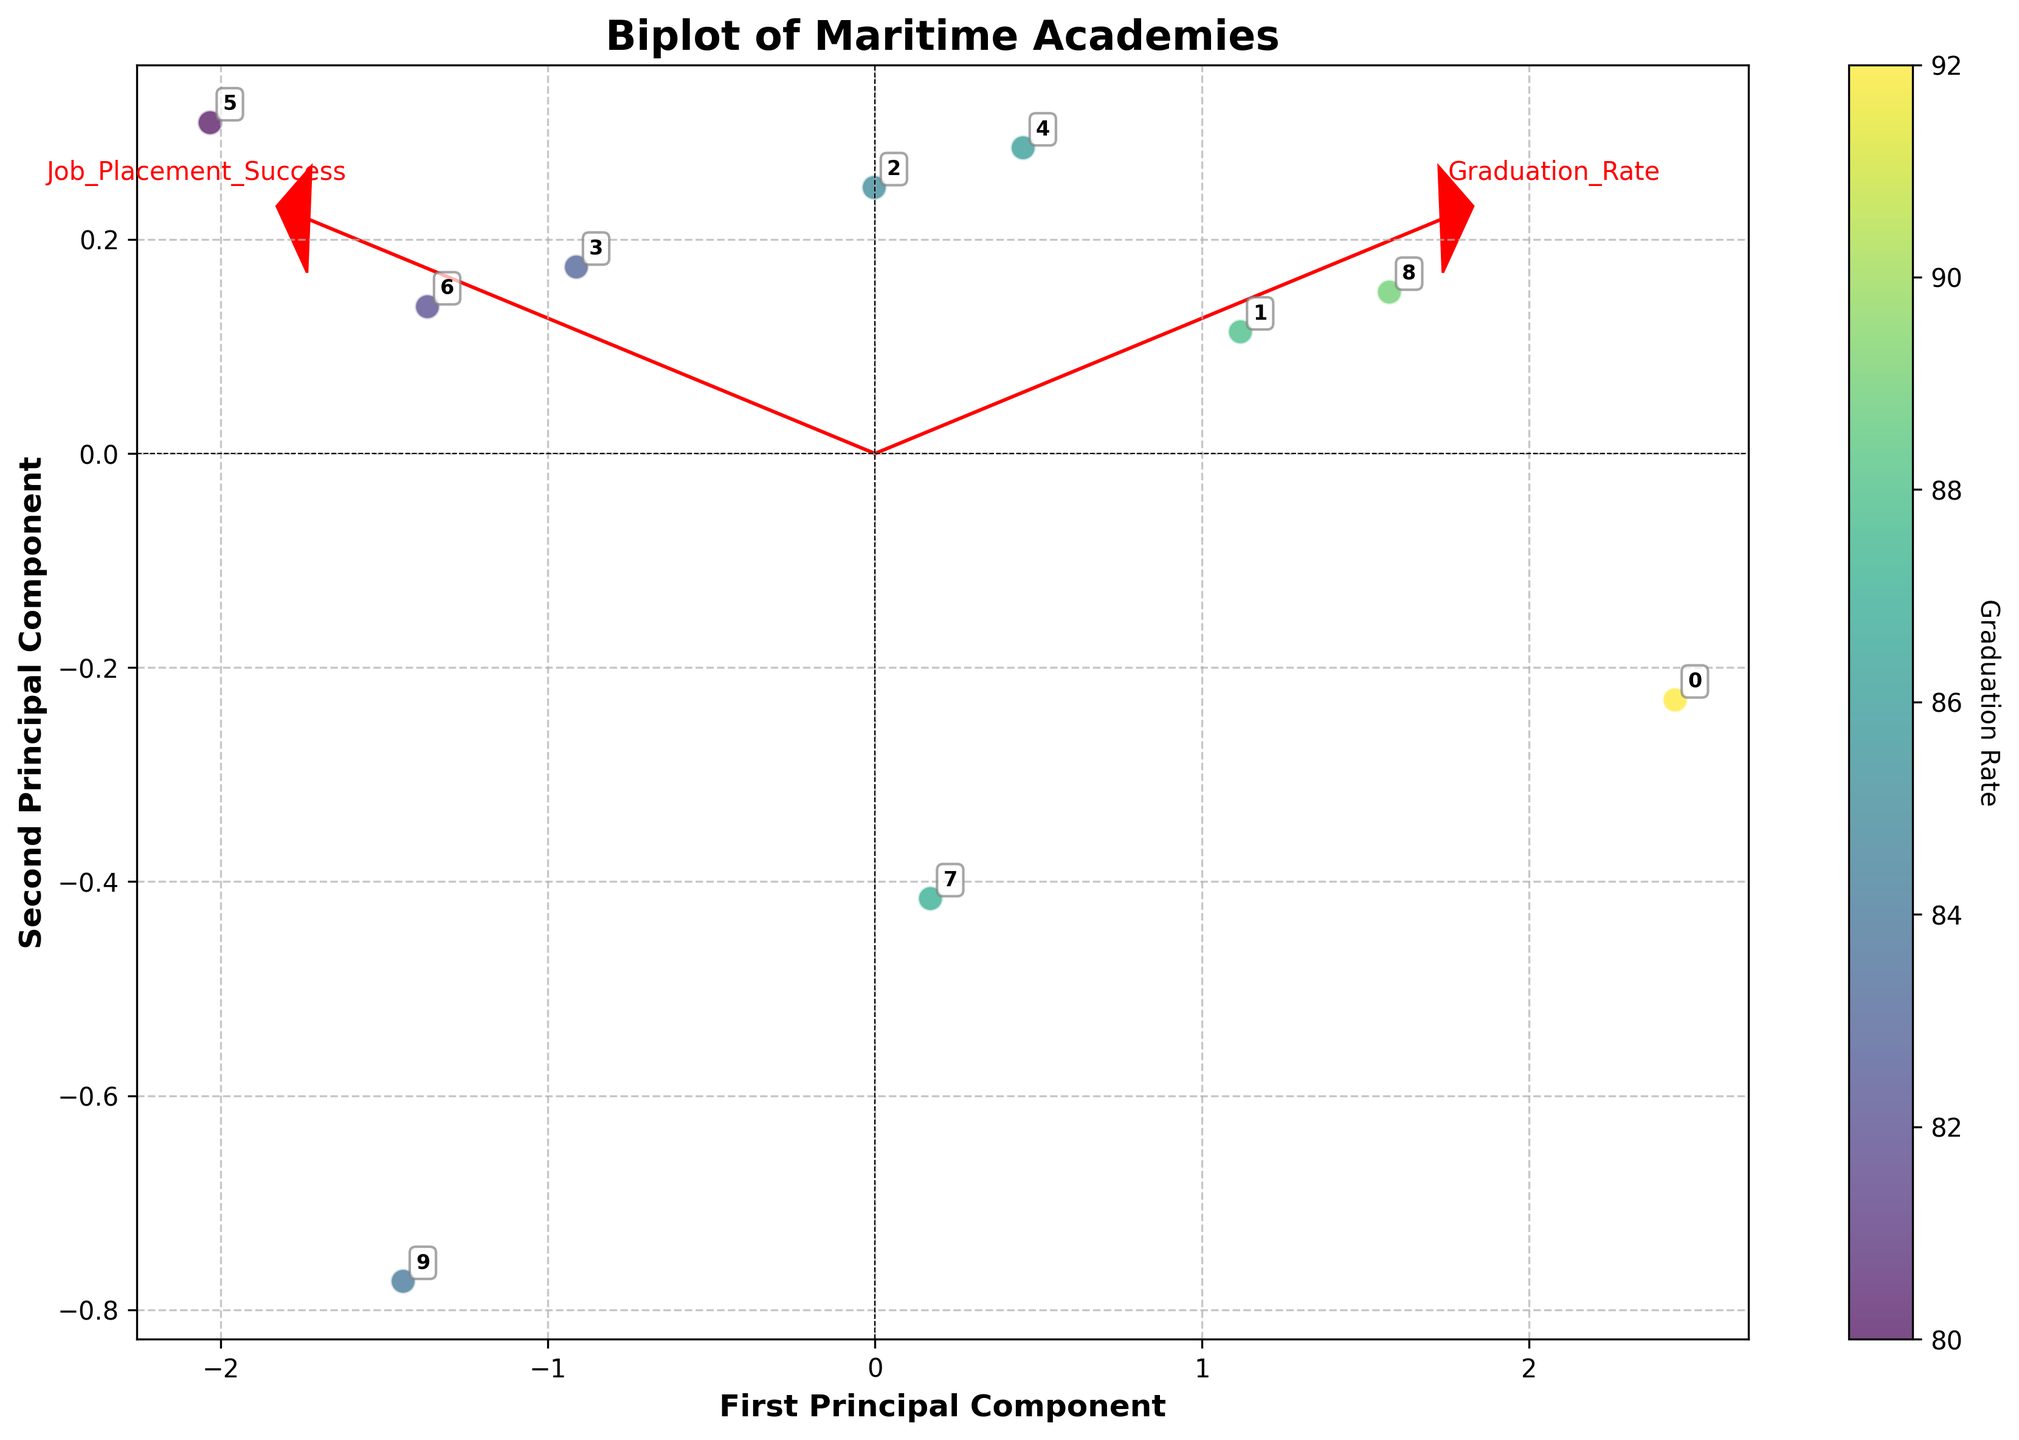How many maritime academies are displayed in the biplot? Count the number of unique points or annotations in the biplot. This corresponds to the number of maritime academies shown.
Answer: 10 Which maritime academy has the highest graduation rate? Look for the point that has the highest value on the color bar, which represents graduation rate. The annotation near this point will represent the academy.
Answer: United States Merchant Marine Academy Which principal component is represented on the x-axis in the biplot? Read the x-axis label on the biplot to identify the principal component.
Answer: First Principal Component If an academy is located near the origin in the biplot, what can be inferred about its standardized values for graduation rate and job placement success? Points near the origin have values close to the mean for both standardized graduation rate and job placement success.
Answer: Close to mean Compare the graduation rate and job placement success of Texas A&M Maritime Academy and SUNY Maritime College. Which one performs better overall? Locate both academies on the biplot. SUNY Maritime College is positioned higher in job placement success and has relatively better graduation rate according to the color gradient.
Answer: SUNY Maritime College What does an arrow in the biplot represent? Arrows represent eigenvectors which indicate the direction of maximum variance for the features (graduation rate and job placement success).
Answer: Eigenvectors of features Which maritime academy is positioned closest to the first principal component? Identify the point that is farthest along the x-axis while being closer to it.
Answer: Australian Maritime College How do the plotted points relate to the direction of the arrows? Points projected in the same direction as an arrow have high values for that feature. The closer the point to the arrow, the stronger the relationship.
Answer: High values correlation Which maritime academy shows a balance between graduation rate and job placement success? Look for points that are positioned proportionally in line with both the arrows for graduation rate and job placement success.
Answer: Netherlands Maritime University 